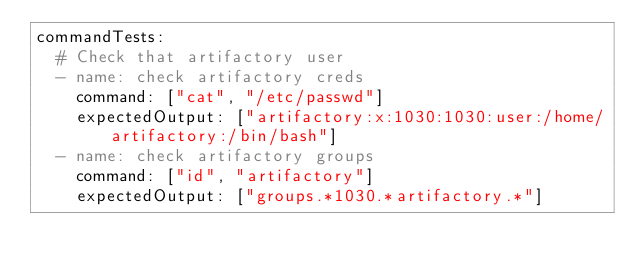Convert code to text. <code><loc_0><loc_0><loc_500><loc_500><_YAML_>commandTests:
  # Check that artifactory user
  - name: check artifactory creds
    command: ["cat", "/etc/passwd"]
    expectedOutput: ["artifactory:x:1030:1030:user:/home/artifactory:/bin/bash"]
  - name: check artifactory groups
    command: ["id", "artifactory"]
    expectedOutput: ["groups.*1030.*artifactory.*"]
</code> 